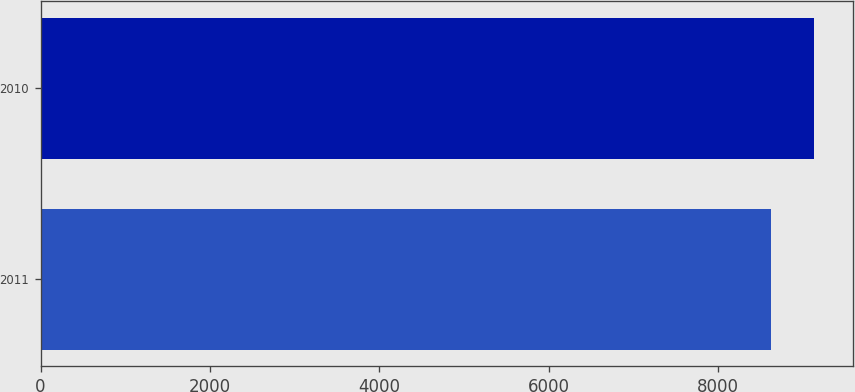Convert chart. <chart><loc_0><loc_0><loc_500><loc_500><bar_chart><fcel>2011<fcel>2010<nl><fcel>8617<fcel>9135<nl></chart> 